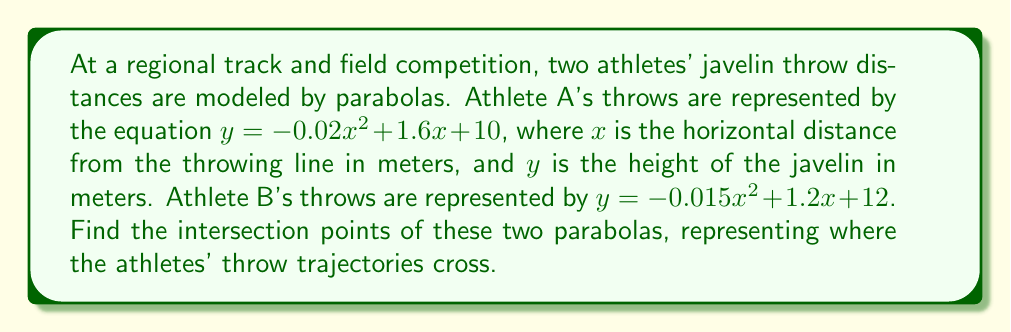Solve this math problem. To find the intersection points, we need to solve the system of equations:

$$\begin{cases}
y = -0.02x^2 + 1.6x + 10 \\
y = -0.015x^2 + 1.2x + 12
\end{cases}$$

1) Set the equations equal to each other:
   $-0.02x^2 + 1.6x + 10 = -0.015x^2 + 1.2x + 12$

2) Subtract the right side from both sides:
   $-0.005x^2 + 0.4x - 2 = 0$

3) Multiply all terms by -200 to eliminate fractions:
   $x^2 - 80x + 400 = 0$

4) This is a quadratic equation. We can solve it using the quadratic formula:
   $x = \frac{-b \pm \sqrt{b^2 - 4ac}}{2a}$

   Where $a = 1$, $b = -80$, and $c = 400$

5) Substituting these values:
   $x = \frac{80 \pm \sqrt{6400 - 1600}}{2} = \frac{80 \pm \sqrt{4800}}{2} = \frac{80 \pm 4\sqrt{300}}{2}$

6) Simplifying:
   $x = 40 \pm 2\sqrt{300}$

7) This gives us two x-coordinates:
   $x_1 = 40 + 2\sqrt{300}$ and $x_2 = 40 - 2\sqrt{300}$

8) To find the y-coordinates, substitute either x value into either original equation. Let's use Athlete A's equation and $x_1$:

   $y = -0.02(40 + 2\sqrt{300})^2 + 1.6(40 + 2\sqrt{300}) + 10$

9) Simplifying this expression (which involves expanding the square and simplifying) gives us the corresponding y-coordinate.

Therefore, the intersection points are $(40 + 2\sqrt{300}, y_1)$ and $(40 - 2\sqrt{300}, y_2)$, where $y_1$ and $y_2$ are the calculated y-values.
Answer: $(40 + 2\sqrt{300}, y_1)$ and $(40 - 2\sqrt{300}, y_2)$ 